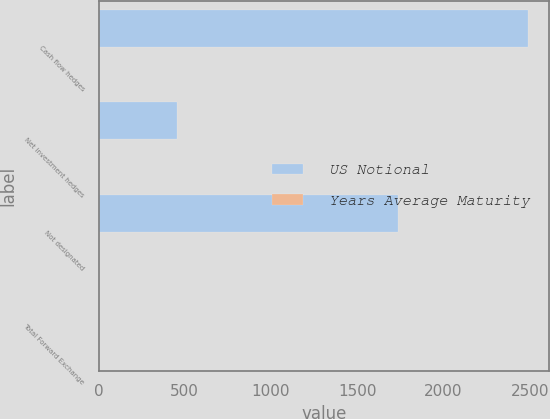Convert chart. <chart><loc_0><loc_0><loc_500><loc_500><stacked_bar_chart><ecel><fcel>Cash flow hedges<fcel>Net investment hedges<fcel>Not designated<fcel>Total Forward Exchange<nl><fcel>US Notional<fcel>2489.1<fcel>457.5<fcel>1736.1<fcel>1.7<nl><fcel>Years Average Maturity<fcel>0.4<fcel>1.7<fcel>0.8<fcel>0.7<nl></chart> 